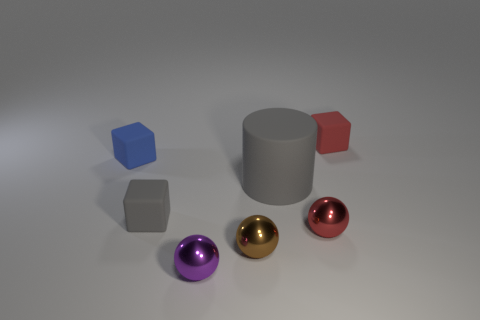There is a tiny matte thing that is the same color as the cylinder; what is its shape?
Ensure brevity in your answer.  Cube. Are there any blue rubber blocks in front of the small red thing that is on the left side of the matte block that is on the right side of the tiny purple thing?
Offer a very short reply. No. How many metallic things are either blue cubes or gray things?
Your answer should be very brief. 0. There is a small gray block; how many gray matte things are in front of it?
Provide a succinct answer. 0. What number of red objects are both to the left of the red matte cube and behind the tiny gray matte block?
Ensure brevity in your answer.  0. There is a red object that is made of the same material as the small purple thing; what is its shape?
Offer a terse response. Sphere. There is a cube on the right side of the purple sphere; is it the same size as the red metallic sphere that is to the right of the tiny gray matte block?
Ensure brevity in your answer.  Yes. The matte object on the right side of the red ball is what color?
Offer a terse response. Red. There is a red thing in front of the small block on the right side of the gray block; what is it made of?
Give a very brief answer. Metal. There is a blue object; what shape is it?
Provide a short and direct response. Cube. 